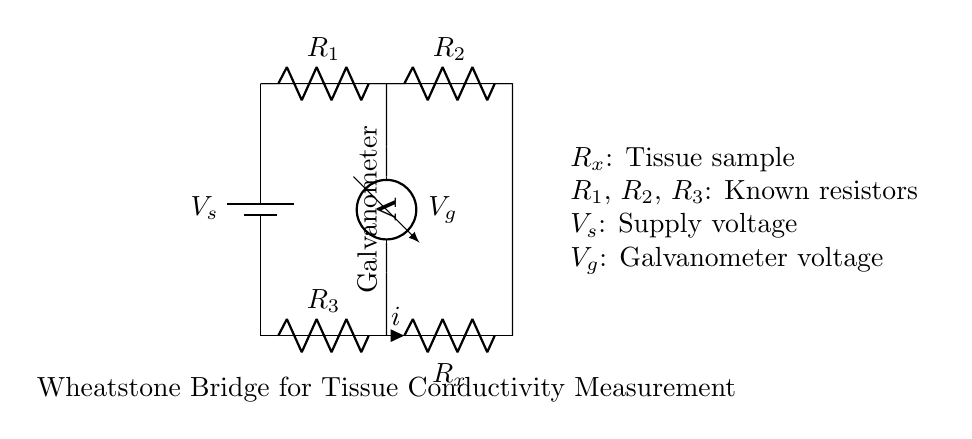What is the supply voltage of this circuit? The supply voltage is indicated by the label "V_s" connected to the battery in the circuit diagram, which usually represents the source voltage.
Answer: V_s Which component represents the tissue sample? The component labeled "R_x" is the resistor that represents the tissue sample in the Wheatstone bridge configuration.
Answer: R_x What is the function of the galvanometer in this circuit? The galvanometer is used to measure the voltage difference between the two points connected to it, indicating whether the bridge is balanced or if there is a difference in resistance.
Answer: Measure voltage How many known resistors are present in the circuit? There are three resistors labeled as "R_1", "R_2", and "R_3" that are known values in the Wheatstone bridge.
Answer: Three What happens to the galvanometer reading if the tissue conductivity increases? If the tissue conductivity increases, the resistance "R_x" decreases, causing more current to flow through the galvanometer, resulting in a change in its reading indicating imbalance.
Answer: Increases What does a zero voltage at the galvanometer indicate? A zero voltage reading at the galvanometer indicates that the Wheatstone bridge is balanced, meaning the ratio of the known resistors matches the resistance of the tissue sample.
Answer: Balanced bridge What is the relationship that governs the balance of this Wheatstone bridge? The relationship is defined by the equation R_1/R_2 = R_3/R_x, where the ratios must be equal for the bridge to be balanced.
Answer: R_1/R_2 = R_3/R_x 